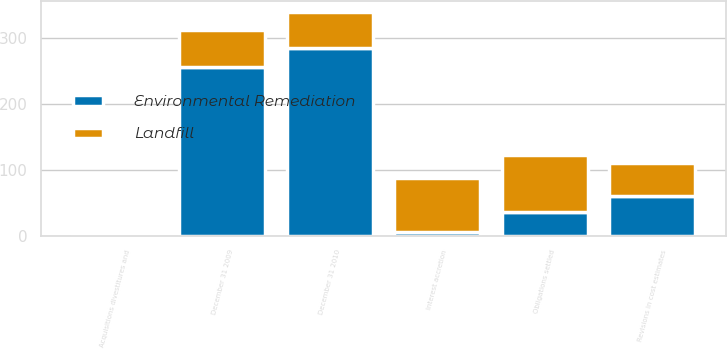Convert chart. <chart><loc_0><loc_0><loc_500><loc_500><stacked_bar_chart><ecel><fcel>December 31 2009<fcel>Obligations settled<fcel>Interest accretion<fcel>Revisions in cost estimates<fcel>Acquisitions divestitures and<fcel>December 31 2010<nl><fcel>Landfill<fcel>55<fcel>86<fcel>82<fcel>49<fcel>5<fcel>55<nl><fcel>Environmental Remediation<fcel>256<fcel>36<fcel>5<fcel>61<fcel>2<fcel>284<nl></chart> 